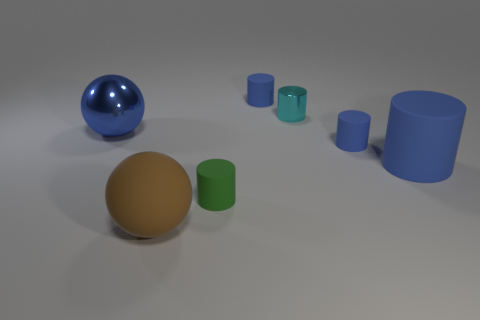Is there a pattern to how the objects are arranged? The objects appear to be arranged by size, with cylinders decreasing in height from right to left. There's also a contrast in shapes, with spherical objects on both sides of the arrangement, creating a visual balance. 